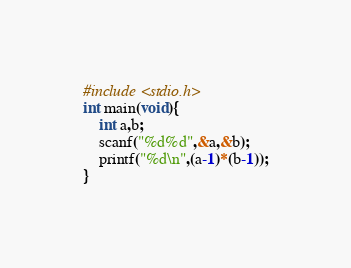Convert code to text. <code><loc_0><loc_0><loc_500><loc_500><_C_>#include <stdio.h>
int main(void){
    int a,b;
    scanf("%d%d",&a,&b);
    printf("%d\n",(a-1)*(b-1));
}</code> 